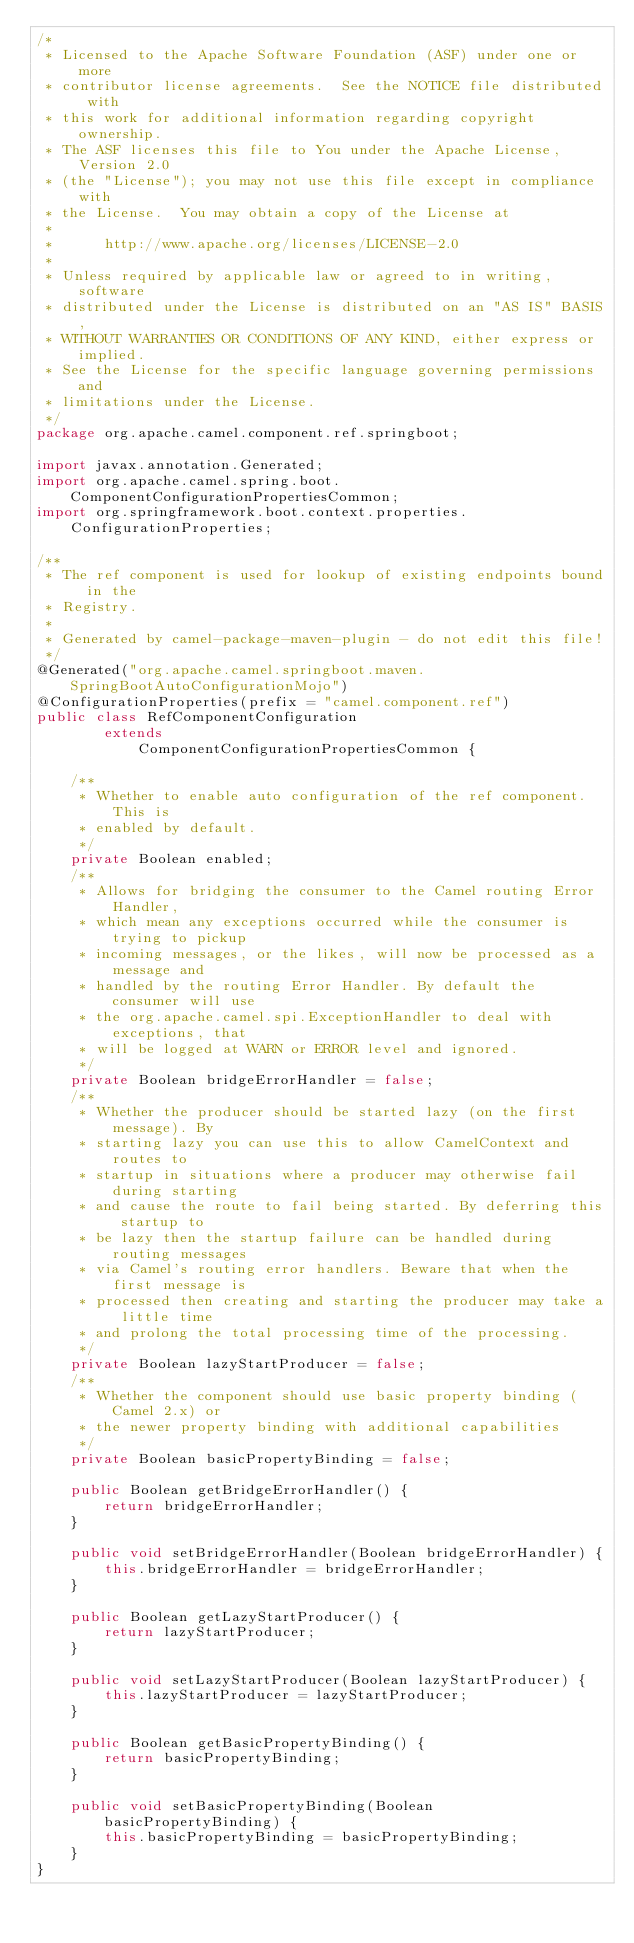Convert code to text. <code><loc_0><loc_0><loc_500><loc_500><_Java_>/*
 * Licensed to the Apache Software Foundation (ASF) under one or more
 * contributor license agreements.  See the NOTICE file distributed with
 * this work for additional information regarding copyright ownership.
 * The ASF licenses this file to You under the Apache License, Version 2.0
 * (the "License"); you may not use this file except in compliance with
 * the License.  You may obtain a copy of the License at
 *
 *      http://www.apache.org/licenses/LICENSE-2.0
 *
 * Unless required by applicable law or agreed to in writing, software
 * distributed under the License is distributed on an "AS IS" BASIS,
 * WITHOUT WARRANTIES OR CONDITIONS OF ANY KIND, either express or implied.
 * See the License for the specific language governing permissions and
 * limitations under the License.
 */
package org.apache.camel.component.ref.springboot;

import javax.annotation.Generated;
import org.apache.camel.spring.boot.ComponentConfigurationPropertiesCommon;
import org.springframework.boot.context.properties.ConfigurationProperties;

/**
 * The ref component is used for lookup of existing endpoints bound in the
 * Registry.
 * 
 * Generated by camel-package-maven-plugin - do not edit this file!
 */
@Generated("org.apache.camel.springboot.maven.SpringBootAutoConfigurationMojo")
@ConfigurationProperties(prefix = "camel.component.ref")
public class RefComponentConfiguration
        extends
            ComponentConfigurationPropertiesCommon {

    /**
     * Whether to enable auto configuration of the ref component. This is
     * enabled by default.
     */
    private Boolean enabled;
    /**
     * Allows for bridging the consumer to the Camel routing Error Handler,
     * which mean any exceptions occurred while the consumer is trying to pickup
     * incoming messages, or the likes, will now be processed as a message and
     * handled by the routing Error Handler. By default the consumer will use
     * the org.apache.camel.spi.ExceptionHandler to deal with exceptions, that
     * will be logged at WARN or ERROR level and ignored.
     */
    private Boolean bridgeErrorHandler = false;
    /**
     * Whether the producer should be started lazy (on the first message). By
     * starting lazy you can use this to allow CamelContext and routes to
     * startup in situations where a producer may otherwise fail during starting
     * and cause the route to fail being started. By deferring this startup to
     * be lazy then the startup failure can be handled during routing messages
     * via Camel's routing error handlers. Beware that when the first message is
     * processed then creating and starting the producer may take a little time
     * and prolong the total processing time of the processing.
     */
    private Boolean lazyStartProducer = false;
    /**
     * Whether the component should use basic property binding (Camel 2.x) or
     * the newer property binding with additional capabilities
     */
    private Boolean basicPropertyBinding = false;

    public Boolean getBridgeErrorHandler() {
        return bridgeErrorHandler;
    }

    public void setBridgeErrorHandler(Boolean bridgeErrorHandler) {
        this.bridgeErrorHandler = bridgeErrorHandler;
    }

    public Boolean getLazyStartProducer() {
        return lazyStartProducer;
    }

    public void setLazyStartProducer(Boolean lazyStartProducer) {
        this.lazyStartProducer = lazyStartProducer;
    }

    public Boolean getBasicPropertyBinding() {
        return basicPropertyBinding;
    }

    public void setBasicPropertyBinding(Boolean basicPropertyBinding) {
        this.basicPropertyBinding = basicPropertyBinding;
    }
}</code> 